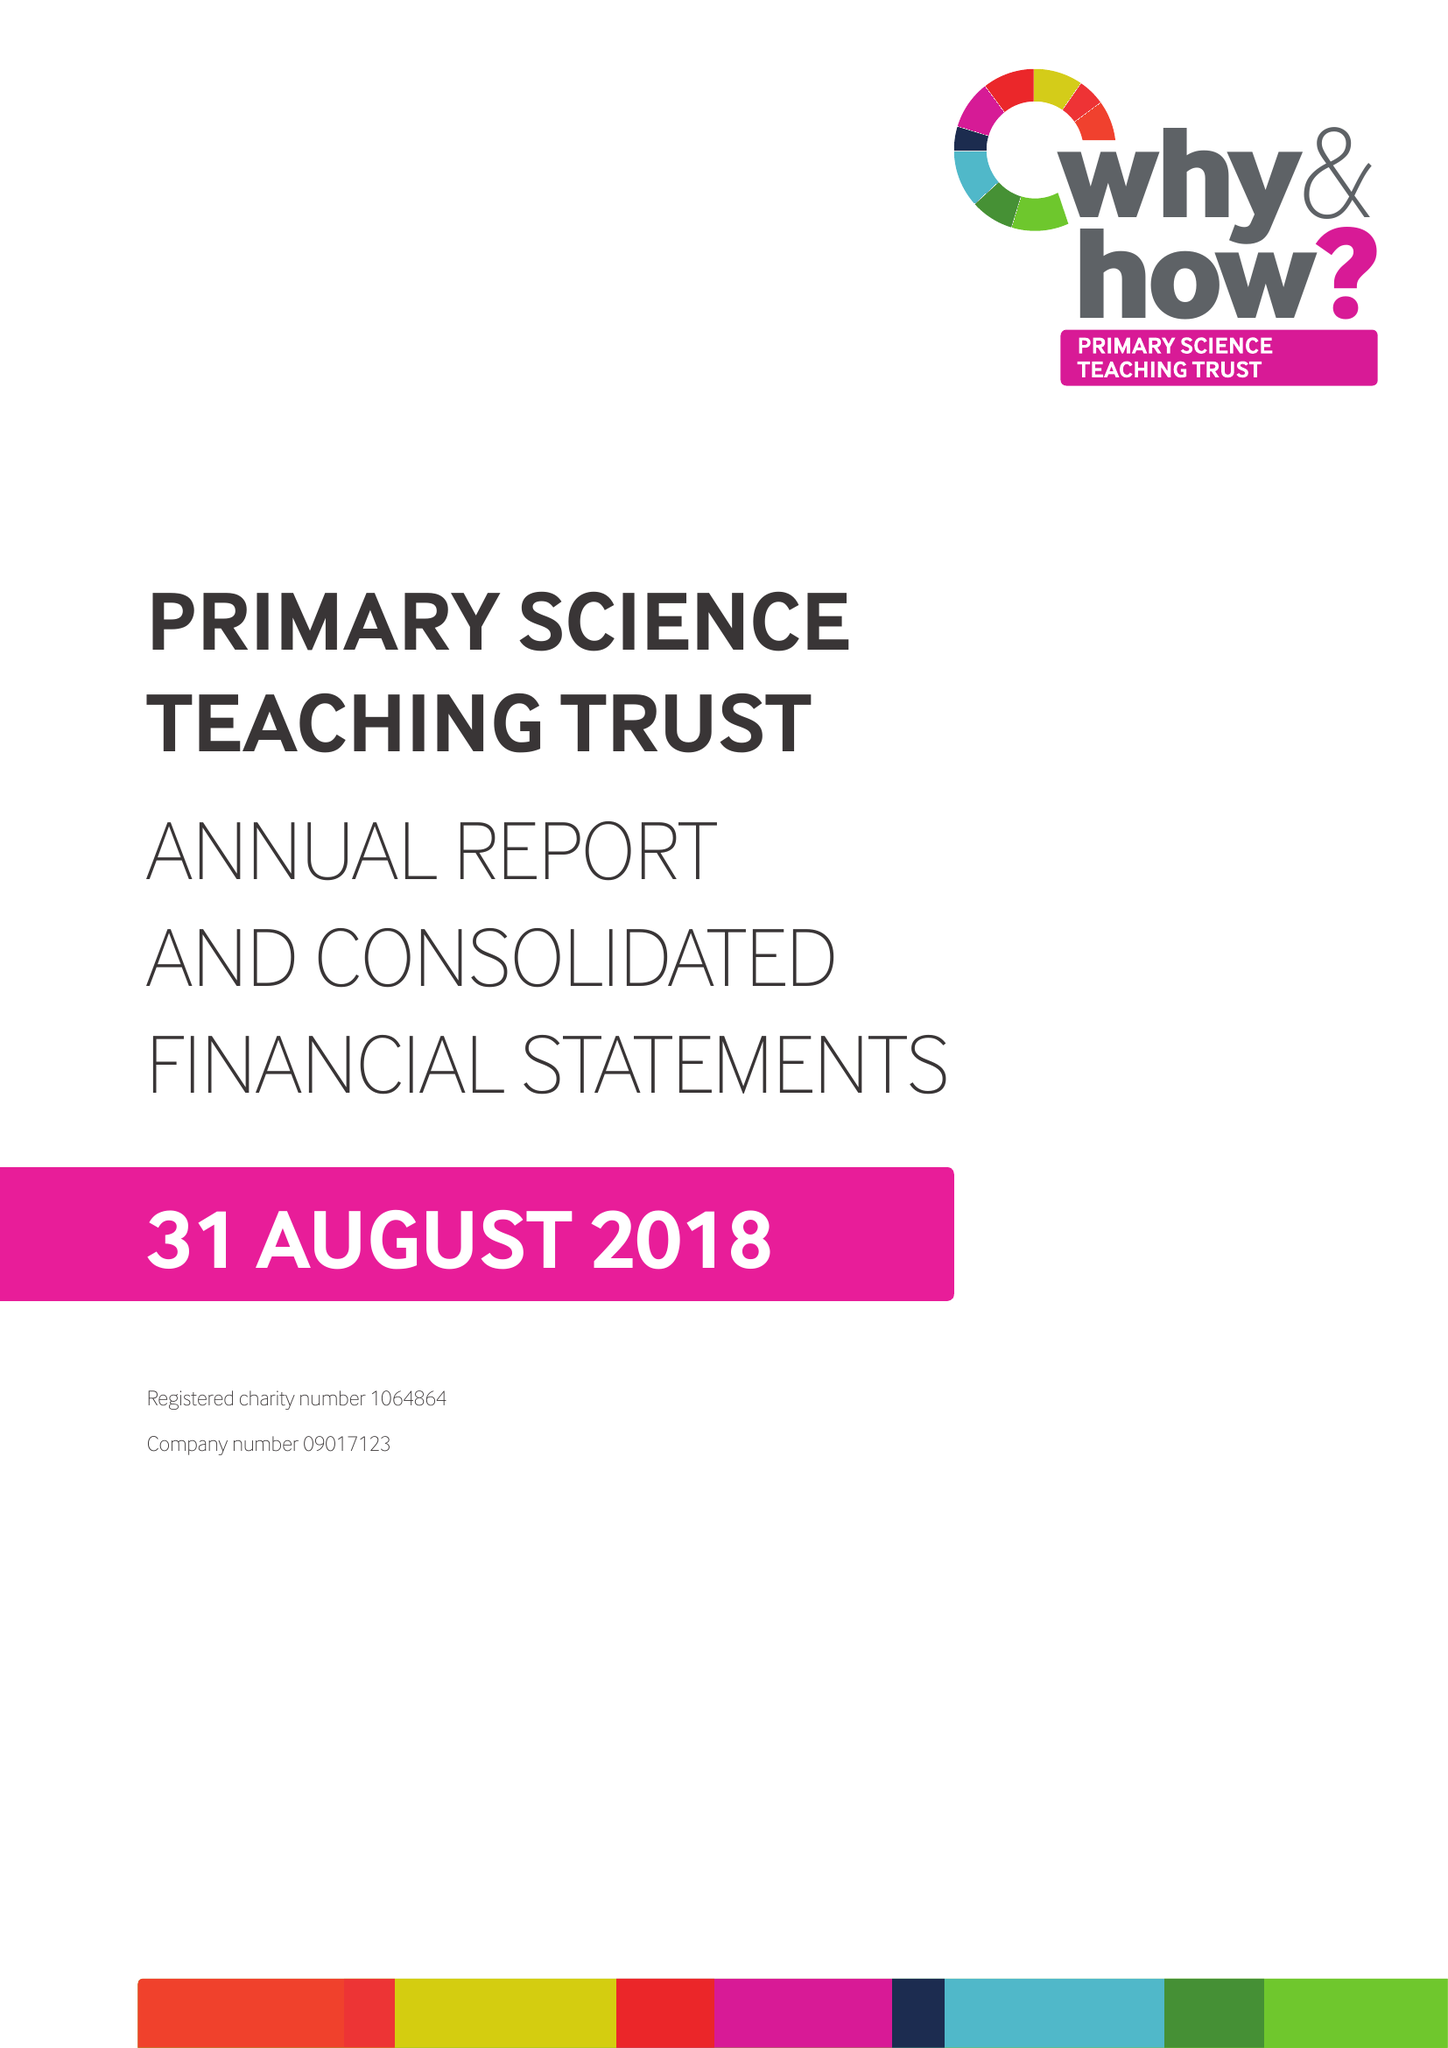What is the value for the address__postcode?
Answer the question using a single word or phrase. BS8 1PD 